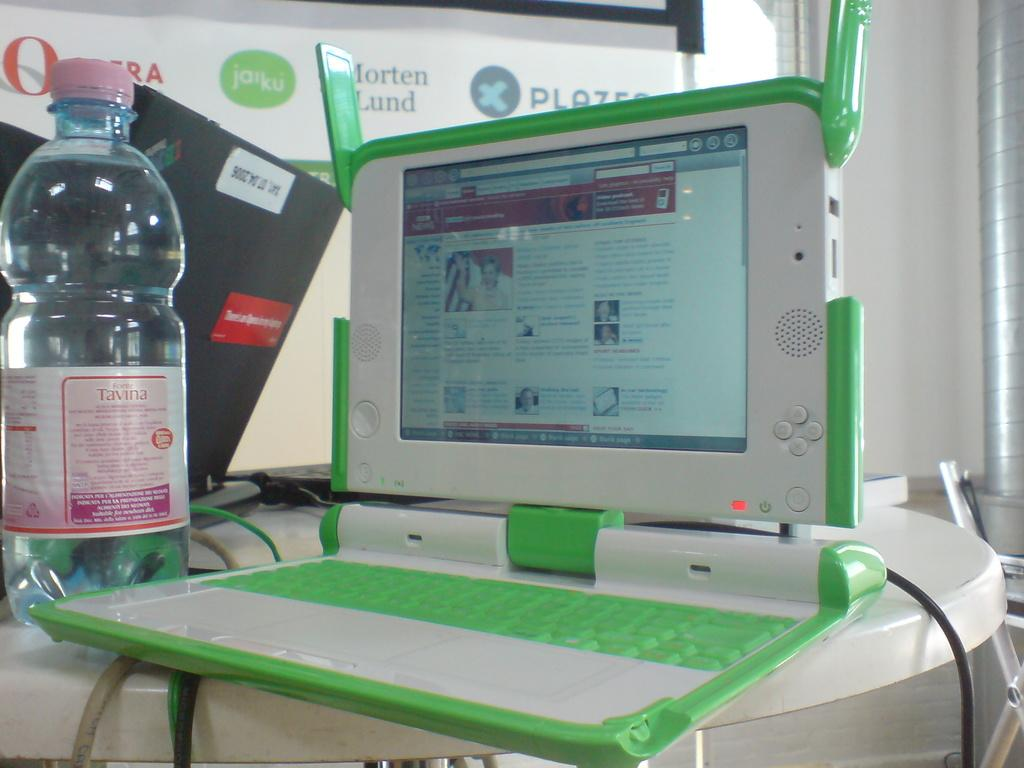<image>
Present a compact description of the photo's key features. A green and white laptop with a bottle that says tavina next to it. 